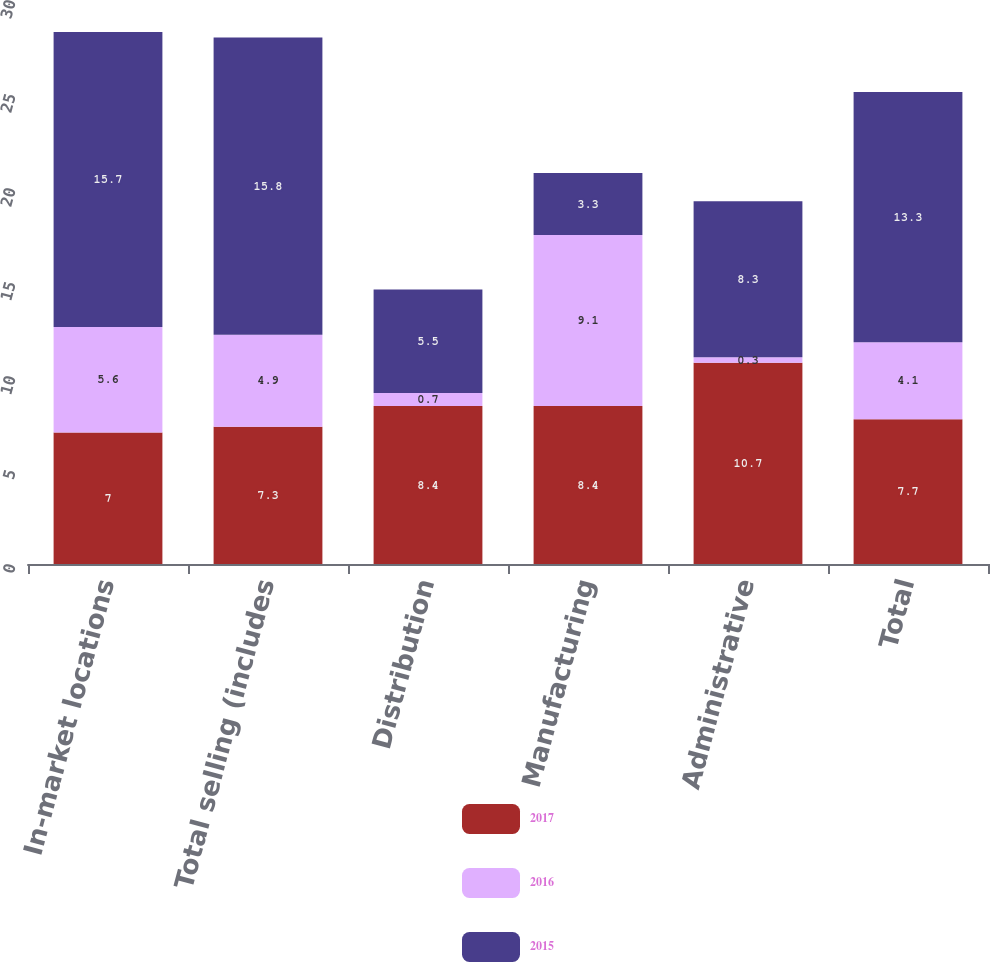Convert chart. <chart><loc_0><loc_0><loc_500><loc_500><stacked_bar_chart><ecel><fcel>In-market locations<fcel>Total selling (includes<fcel>Distribution<fcel>Manufacturing<fcel>Administrative<fcel>Total<nl><fcel>2017<fcel>7<fcel>7.3<fcel>8.4<fcel>8.4<fcel>10.7<fcel>7.7<nl><fcel>2016<fcel>5.6<fcel>4.9<fcel>0.7<fcel>9.1<fcel>0.3<fcel>4.1<nl><fcel>2015<fcel>15.7<fcel>15.8<fcel>5.5<fcel>3.3<fcel>8.3<fcel>13.3<nl></chart> 